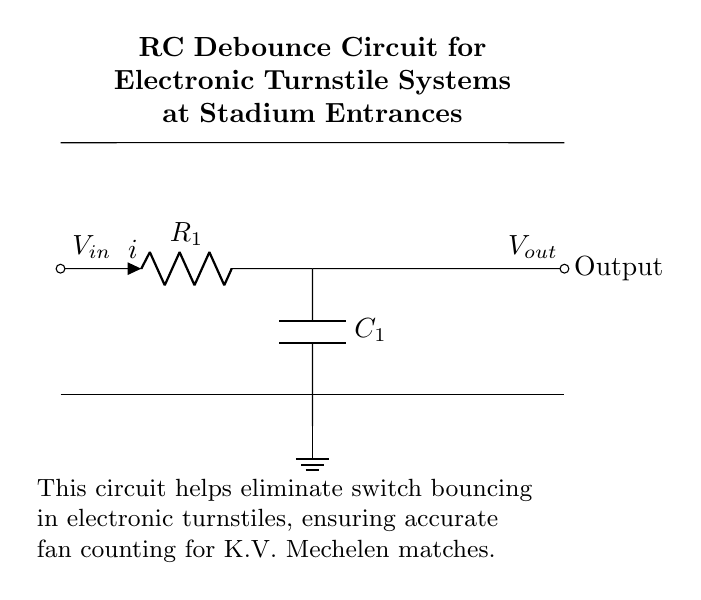What components are in this circuit? The circuit includes a resistor, a capacitor, and a ground connection. Each component is identified in the diagram: R represents the resistor, C represents the capacitor, and there is a symbol for ground.
Answer: resistor, capacitor, ground What is the purpose of the capacitor in this RC circuit? The capacitor in this circuit serves to eliminate switch bouncing, which is a common problem with mechanical switches. By charging and discharging, it smooths the transition of signals to provide a stable output when the switch is activated.
Answer: eliminate switch bouncing What is the labeled current in the circuit? The current is indicated by the label "i" next to the resistor in the circuit diagram. This labeling identifies the direction of current flow through R as part of the analysis of the circuit's operation.
Answer: i How does the output voltage relate to the input voltage in this RC debounce circuit? The output voltage reflects the input voltage with a delay due to the behavior of the capacitor. When the switch closes, the capacitor charges through the resistor, and the output voltage rise will follow a characteristic exponential curve. This is critical for preventing erroneous counts in the turnstile system.
Answer: delayed exponential rise What happens to the output when the input signal rapidly toggles? When the input toggles rapidly, the capacitor reacts to the changes in voltage. It acts as a temporary storage for the charge, which smooths out the abrupt changes caused by switch bouncing, resulting in a cleaner signal. This is crucial for accurate counting in turnstile applications.
Answer: smoother signal What type of circuit is shown? This is an RC debounce circuit, which is specifically designed to eliminate noise in digital signal applications, particularly where mechanical switches are used. The circuit's configuration—using both a resistor and a capacitor—defines it as an RC circuit.
Answer: RC debounce circuit 